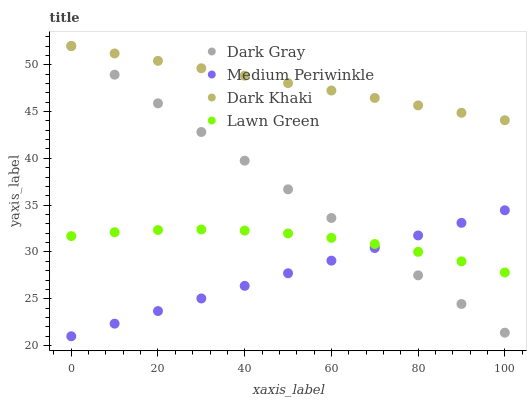Does Medium Periwinkle have the minimum area under the curve?
Answer yes or no. Yes. Does Dark Khaki have the maximum area under the curve?
Answer yes or no. Yes. Does Dark Khaki have the minimum area under the curve?
Answer yes or no. No. Does Medium Periwinkle have the maximum area under the curve?
Answer yes or no. No. Is Medium Periwinkle the smoothest?
Answer yes or no. Yes. Is Lawn Green the roughest?
Answer yes or no. Yes. Is Dark Khaki the smoothest?
Answer yes or no. No. Is Dark Khaki the roughest?
Answer yes or no. No. Does Medium Periwinkle have the lowest value?
Answer yes or no. Yes. Does Dark Khaki have the lowest value?
Answer yes or no. No. Does Dark Khaki have the highest value?
Answer yes or no. Yes. Does Medium Periwinkle have the highest value?
Answer yes or no. No. Is Lawn Green less than Dark Khaki?
Answer yes or no. Yes. Is Dark Khaki greater than Medium Periwinkle?
Answer yes or no. Yes. Does Dark Gray intersect Lawn Green?
Answer yes or no. Yes. Is Dark Gray less than Lawn Green?
Answer yes or no. No. Is Dark Gray greater than Lawn Green?
Answer yes or no. No. Does Lawn Green intersect Dark Khaki?
Answer yes or no. No. 